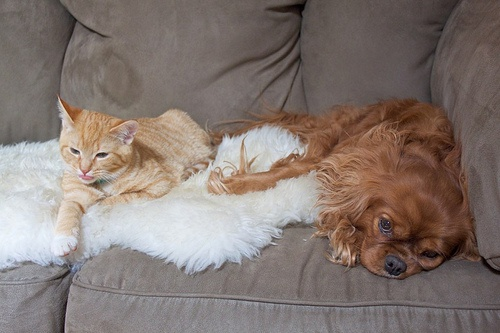Describe the objects in this image and their specific colors. I can see couch in gray and black tones, dog in gray, maroon, and brown tones, and cat in gray, tan, and lightgray tones in this image. 